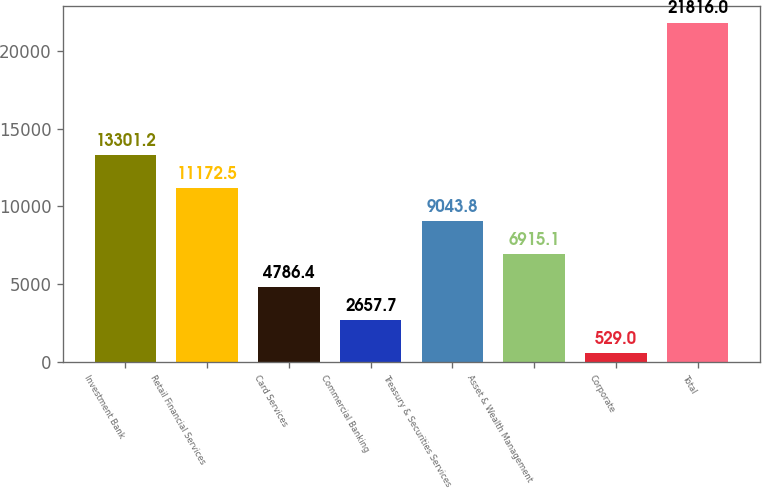Convert chart. <chart><loc_0><loc_0><loc_500><loc_500><bar_chart><fcel>Investment Bank<fcel>Retail Financial Services<fcel>Card Services<fcel>Commercial Banking<fcel>Treasury & Securities Services<fcel>Asset & Wealth Management<fcel>Corporate<fcel>Total<nl><fcel>13301.2<fcel>11172.5<fcel>4786.4<fcel>2657.7<fcel>9043.8<fcel>6915.1<fcel>529<fcel>21816<nl></chart> 